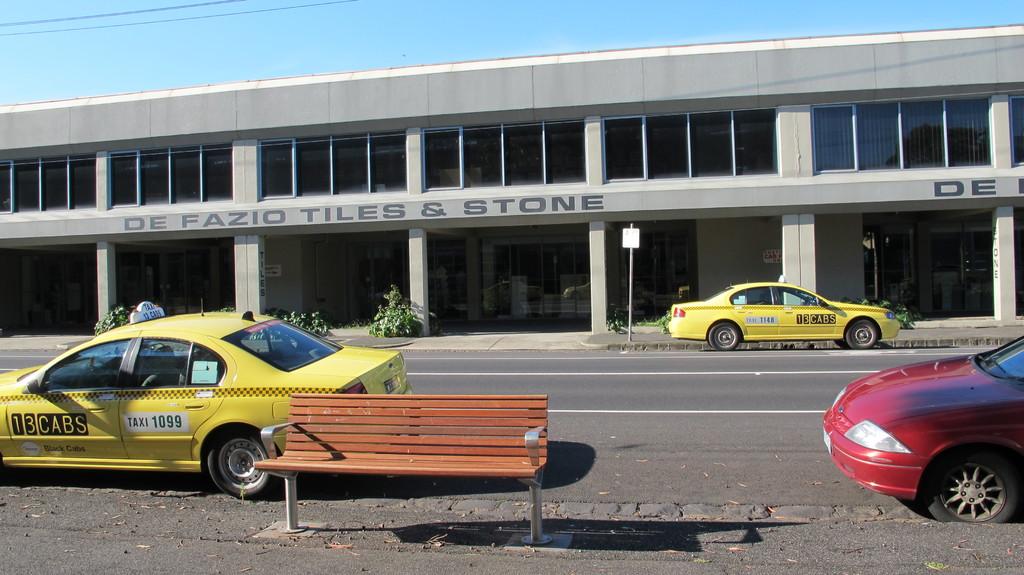What is the company name on the building?
Your answer should be compact. De fazio tiles & stone. 